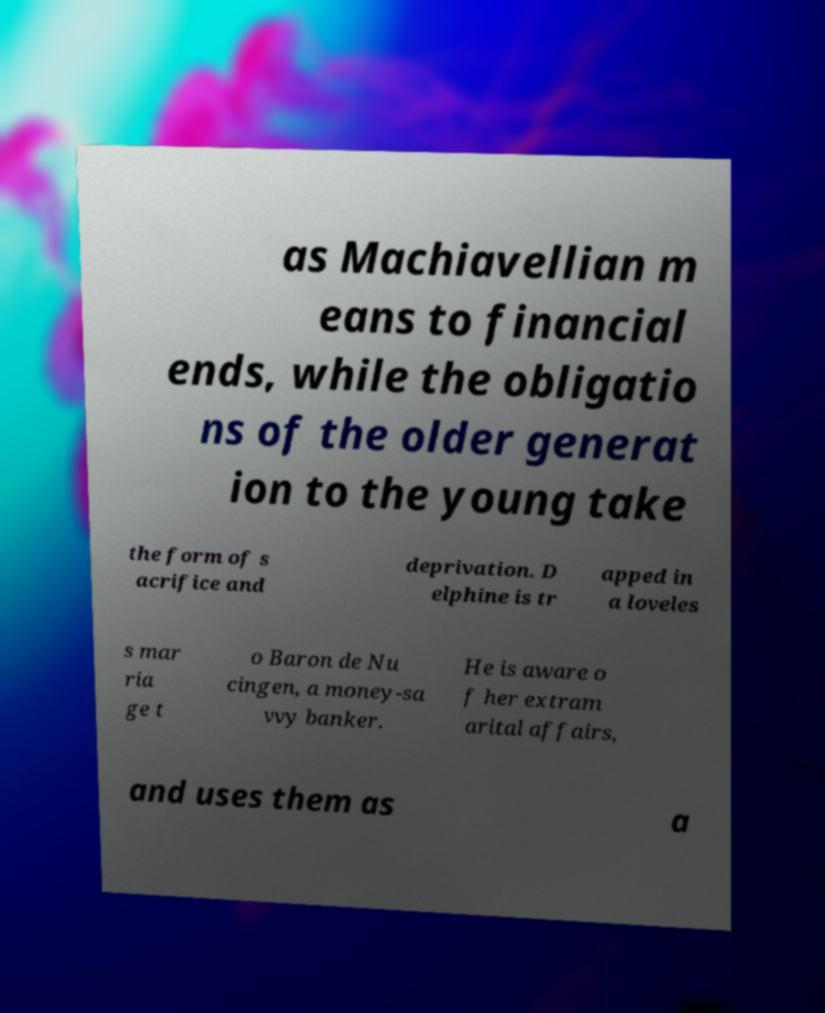For documentation purposes, I need the text within this image transcribed. Could you provide that? as Machiavellian m eans to financial ends, while the obligatio ns of the older generat ion to the young take the form of s acrifice and deprivation. D elphine is tr apped in a loveles s mar ria ge t o Baron de Nu cingen, a money-sa vvy banker. He is aware o f her extram arital affairs, and uses them as a 